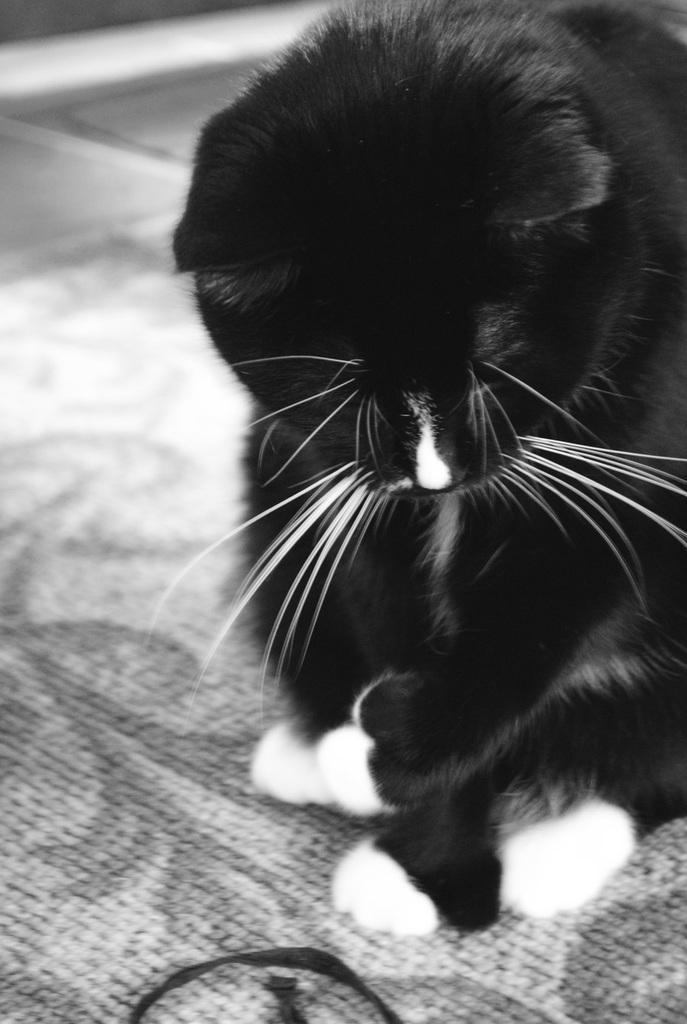What type of animal is present in the image? There is a cat in the image. Where is the cat located in the image? The cat is on the floor. What type of apparel is the cat wearing in the image? The cat is not wearing any apparel in the image. How does the cat show care for its teeth in the image? The image does not show the cat's teeth or any actions related to dental care. 